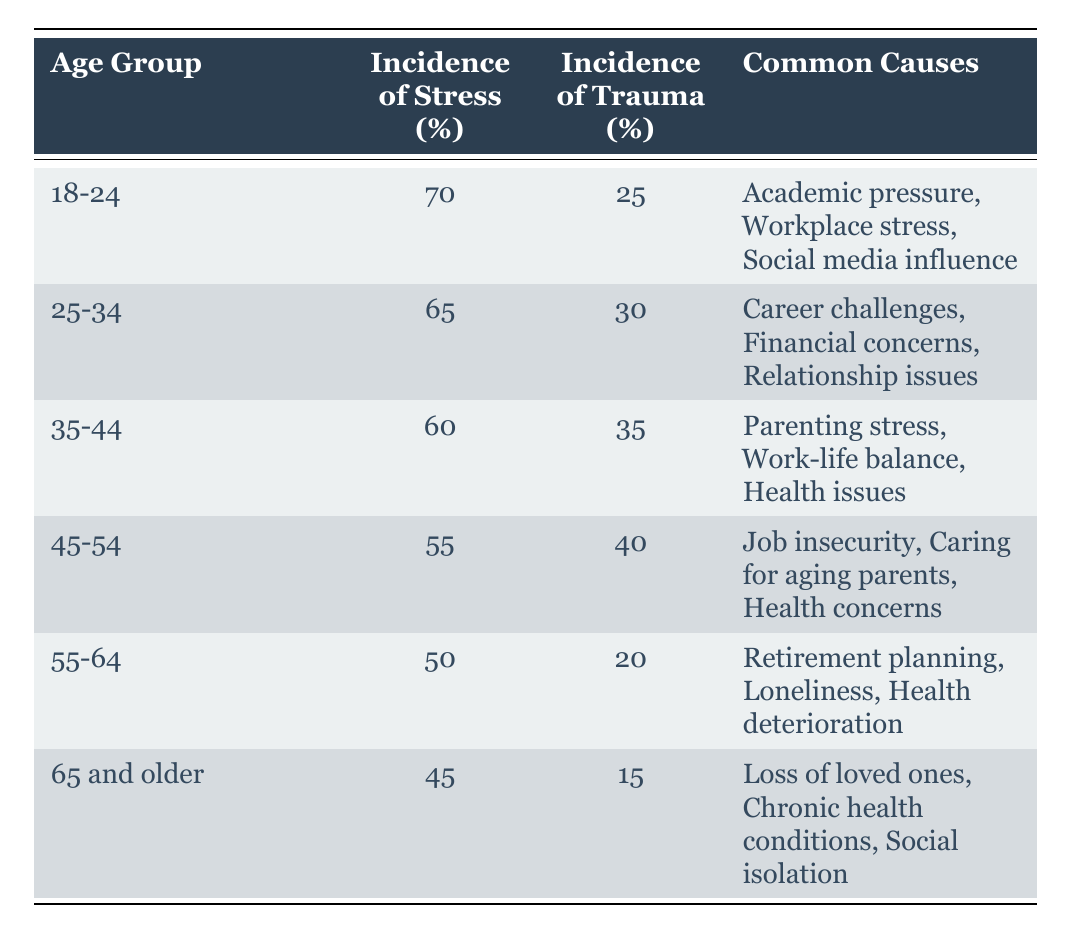What is the incidence of stress for the age group 25-34? From the table, we can look at the row for age group 25-34 where the incidence of stress is listed directly as 65%.
Answer: 65% Which age group has the highest incidence of trauma? By examining the column for incidence of trauma, the age group 45-54 has the highest value at 40%.
Answer: 45-54 Is the incidence of stress lower for those aged 65 and older compared to those aged 35-44? Yes, the incidence of stress for 65 and older is 45%, which is lower than the 60% for the 35-44 age group.
Answer: Yes What is the average incidence of stress across all age groups? To find the average, sum the incidence of stress values (70 + 65 + 60 + 55 + 50 + 45 = 405) and divide by the number of age groups (6). Therefore, 405 / 6 = 67.5%.
Answer: 67.5% How many age groups have an incidence of trauma greater than 25%? The age groups with trauma incidences above 25% are 25-34 (30%), 35-44 (35%), 45-54 (40%), and 18-24 (25%, which does not qualify), giving a total of 3 age groups.
Answer: 3 Which common cause of stress is reported for the age group 55-64? By checking the common causes listed for the age group 55-64, we see that it includes "Retirement planning," "Loneliness," and "Health deterioration."
Answer: Retirement planning, Loneliness, Health deterioration What is the difference in incidence of trauma between the age groups 18-24 and 45-54? The incidence of trauma for 18-24 is 25%, and for 45-54 it is 40%. The difference is 40% - 25% = 15%.
Answer: 15% Do individuals aged 55-64 report a lower incidence of trauma compared to those aged 45-54? Yes, individuals aged 55-64 report a trauma incidence of 20%, which is lower than the 40% reported by those aged 45-54.
Answer: Yes 